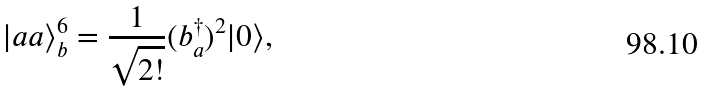<formula> <loc_0><loc_0><loc_500><loc_500>| a a \rangle _ { b } ^ { 6 } = \frac { 1 } { \sqrt { 2 ! } } ( b _ { a } ^ { \dagger } ) ^ { 2 } | 0 \rangle ,</formula> 